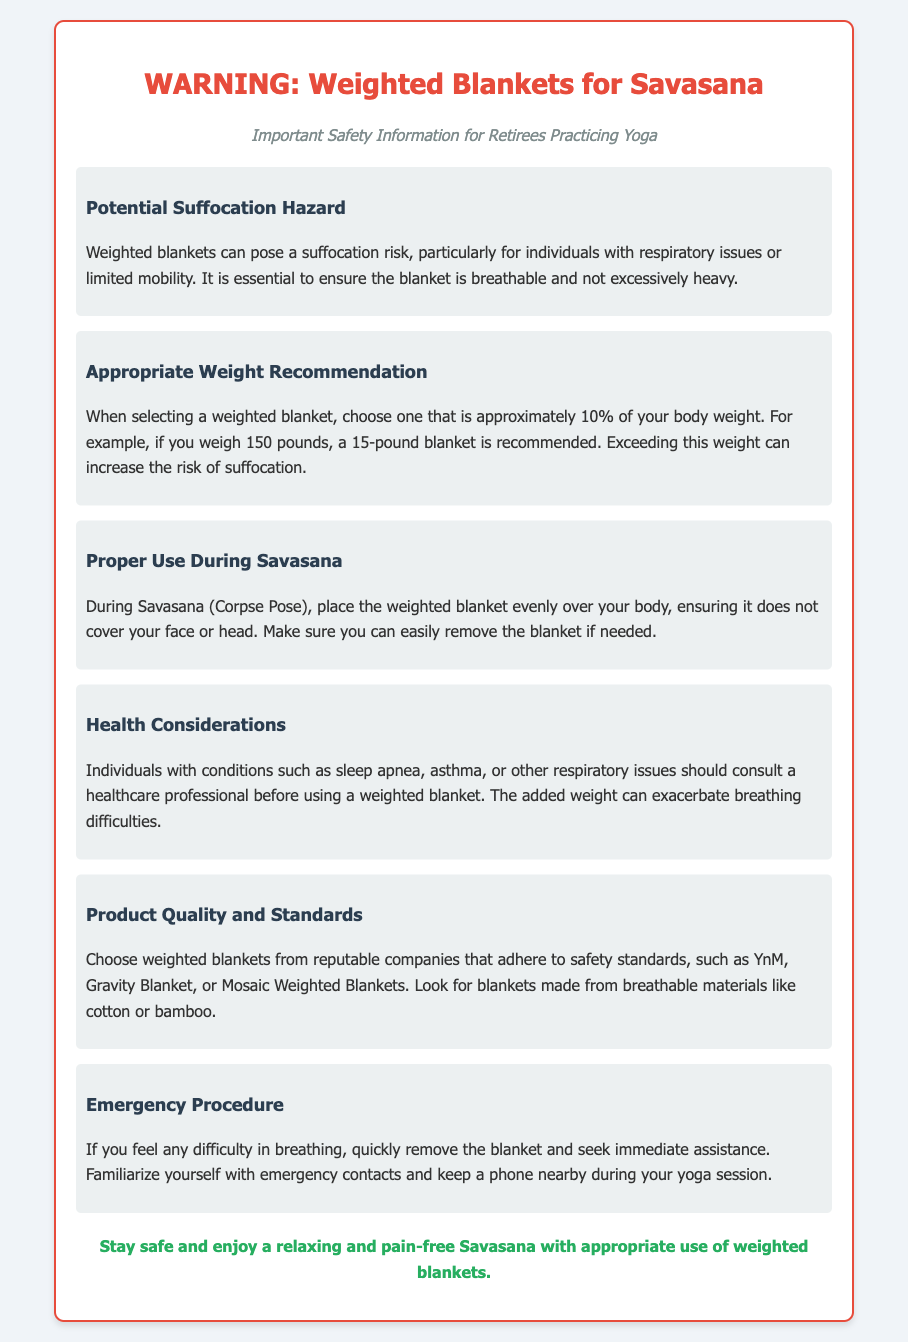What is the main warning regarding weighted blankets? The document warns about the potential suffocation hazard posed by weighted blankets.
Answer: Suffocation hazard What is the recommended weight for a 150-pound individual? The recommended weight for a 150-pound individual is approximately 10% of their body weight, which is 15 pounds.
Answer: 15 pounds What is a key health consideration mentioned? Individuals with respiratory issues should consult a healthcare professional before using a weighted blanket.
Answer: Respiratory issues What should you do if you feel difficulty in breathing? If you feel difficulty in breathing, you should quickly remove the blanket and seek immediate assistance.
Answer: Remove the blanket What materials are suggested for quality weighted blankets? The document suggests looking for blankets made from breathable materials like cotton or bamboo.
Answer: Cotton or bamboo How should a weighted blanket be placed during Savasana? The blanket should be placed evenly over the body, ensuring it does not cover the face or head.
Answer: Evenly over the body What companies are recommended for purchasing weighted blankets? The document mentions reputable companies such as YnM, Gravity Blanket, or Mosaic Weighted Blankets.
Answer: YnM, Gravity Blanket, or Mosaic Weighted Blankets What is the subtitle of the warning label? The subtitle emphasizes the importance of safety information for retirees practicing yoga.
Answer: Important Safety Information for Retirees Practicing Yoga 